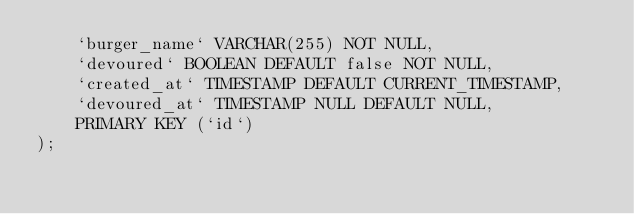<code> <loc_0><loc_0><loc_500><loc_500><_SQL_>	`burger_name` VARCHAR(255) NOT NULL,
	`devoured` BOOLEAN DEFAULT false NOT NULL,
	`created_at` TIMESTAMP DEFAULT CURRENT_TIMESTAMP,
	`devoured_at` TIMESTAMP NULL DEFAULT NULL,
	PRIMARY KEY (`id`)
);</code> 